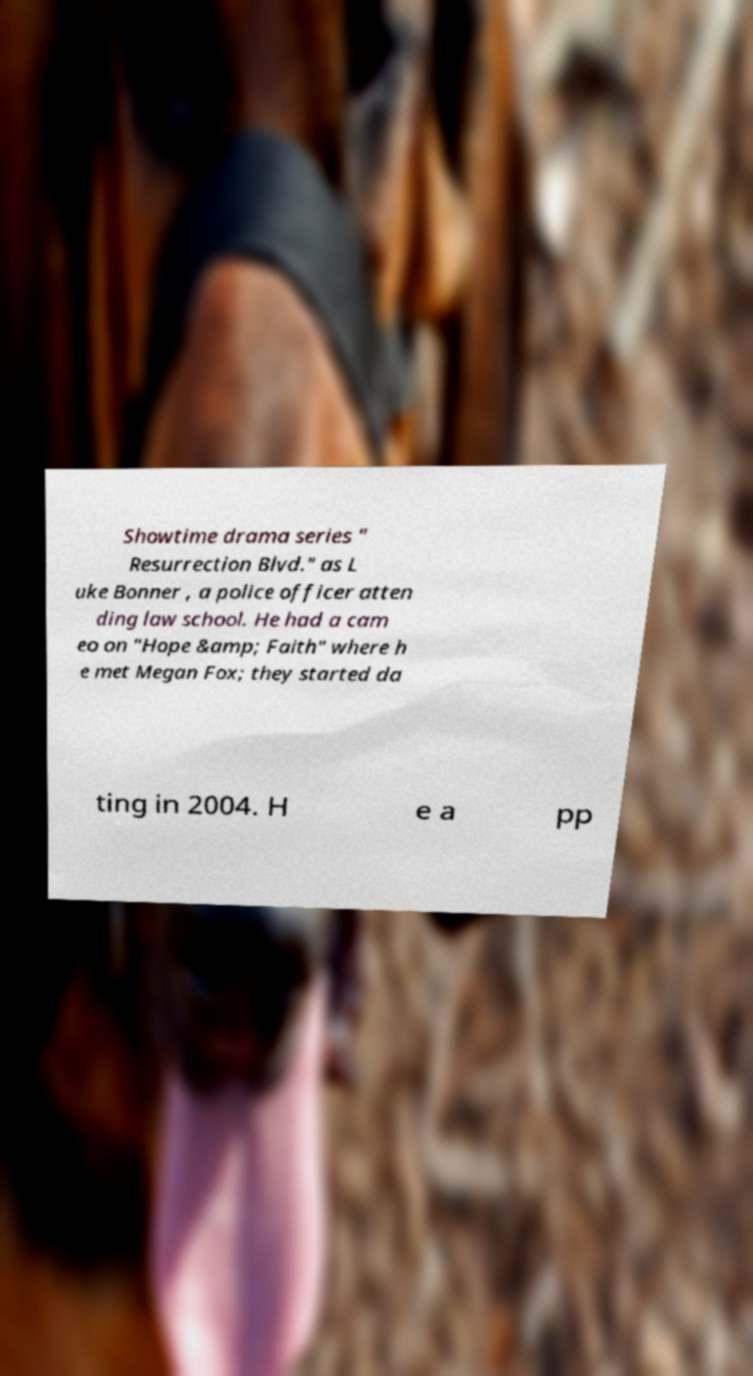Please read and relay the text visible in this image. What does it say? Showtime drama series " Resurrection Blvd." as L uke Bonner , a police officer atten ding law school. He had a cam eo on "Hope &amp; Faith" where h e met Megan Fox; they started da ting in 2004. H e a pp 